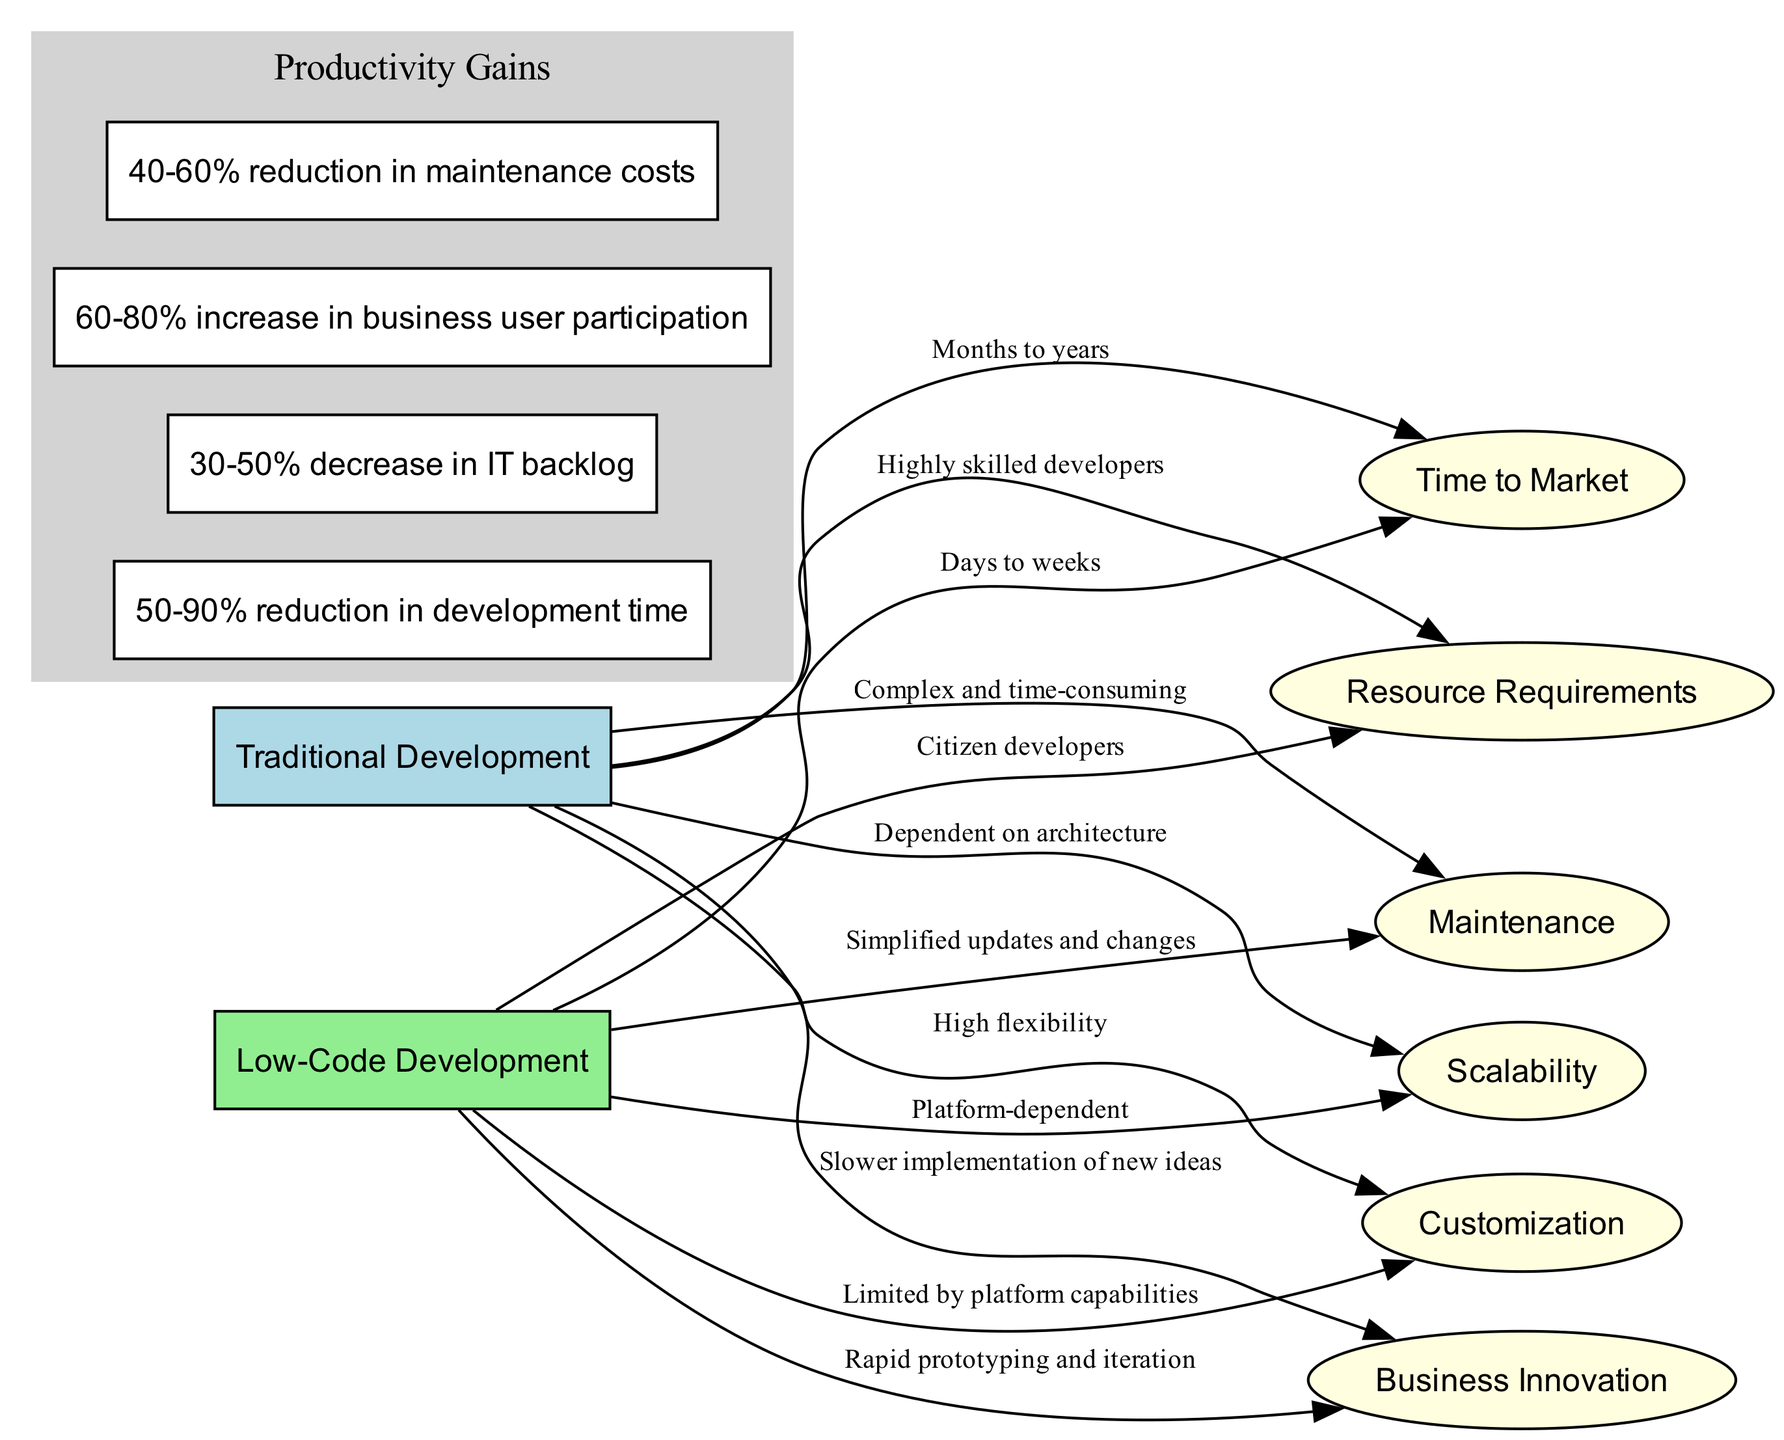What is the time to market for traditional development? In the "Traditional Development" section, the "Time to Market" label indicates “Months to years” under the corresponding edge.
Answer: Months to years What is the primary resource requirement for low-code development? Looking at the "Low-Code Development" section, the resource listed under "Resource Requirements" shows “Citizen developers”.
Answer: Citizen developers Which development approach offers better maintenance? Comparing the "Maintenance" nodes, "Traditional Development" states "Complex and time-consuming" versus "Simplified updates and changes" for "Low-Code Development", indicating that low-code is better.
Answer: Low-Code Development How many productivity gains are listed in the diagram? There are four nodes listed in the "Productivity Gains" cluster, indicating the number of gains presented in the diagram.
Answer: 4 What is the main customization capability of traditional development? Under the "Customization" label for "Traditional Development", it states "High flexibility", describing its main capability in this area.
Answer: High flexibility What is the stated percentage decrease in IT backlog due to low-code platforms? The second productivity gain indicates a "30-50% decrease in IT backlog", indicating the impact of low-code development on IT tasks.
Answer: 30-50% Which development approach is associated with quicker business innovation? The "Business Innovation" label under low-code reads "Rapid prototyping and iteration", suggesting that it leads to quicker innovation compared to traditional methods.
Answer: Low-Code Development What kind of customization limitation is noted for low-code development? The "Customization" node for "Low-Code Development" indicates "Limited by platform capabilities", signaling its constraints.
Answer: Limited by platform capabilities Which approach is viewed as slower for new idea implementation? Reviewing the "Business Innovation" label in traditional development, it states "Slower implementation of new ideas", establishing its slower pace compared to low-code.
Answer: Traditional Development 